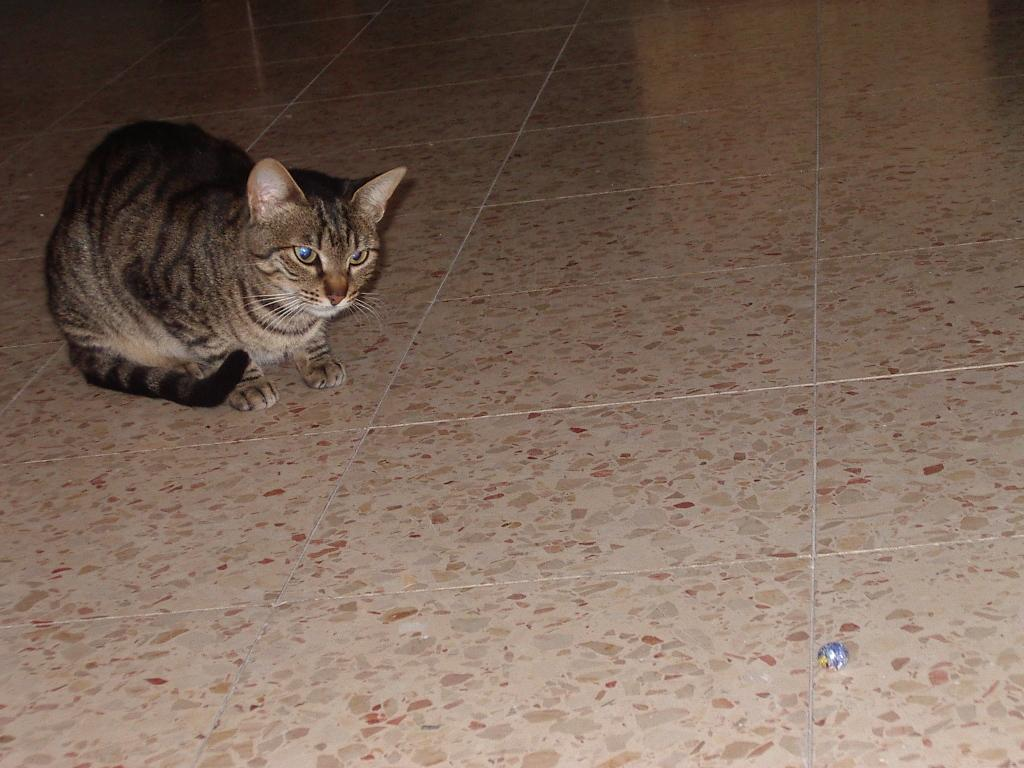What type of animal is in the image? There is a cat in the image. Can you describe the cat's appearance? The cat has brown, black, and cream colors. What color is the floor in the image? The floor in the image is cream-colored. What type of food is the cat eating in the image? There is no food present in the image, so it cannot be determined what the cat might be eating. 